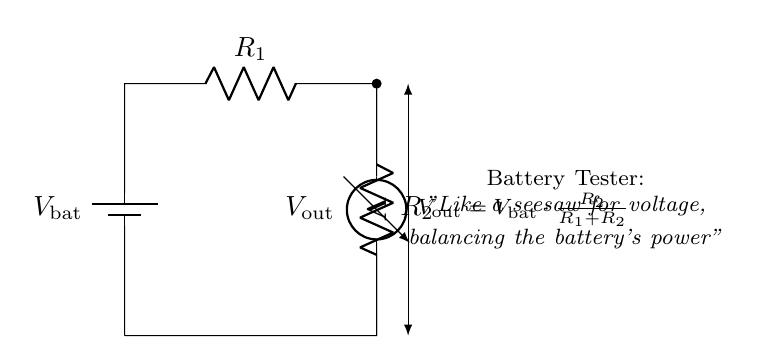What is the purpose of the voltage divider? The voltage divider is used to drop the battery voltage to a lower level suitable for measuring. It allows the voltmeter to display a proportional voltage based on the resistors used.
Answer: To obtain a lower voltage for measurement What are the values of the resistors? The resistors are labeled as R1 and R2, but specific numerical values are not provided in the diagram. Instead, their behavior is defined by their relative sizes in the voltage divider formula.
Answer: R1 and R2 (values not specified) What is the output voltage in relation to the battery voltage? The output voltage, labeled as Vout, is given by the formula Vout = Vbat multiplied by the ratio of R2 to the sum of R1 and R2. This relationship reveals how the voltage is shared between the resistors.
Answer: Vout = Vbat * (R2 / (R1 + R2)) What component measures the voltage? The voltmeter component in the circuit is responsible for measuring the output voltage across R2. It indicates the voltage level at that point in the circuit.
Answer: Voltmeter Why is the battery considered a low-power source? The battery is assumed to be a low-power source because it is likely providing a small amount of current, which is typical for applications like testing batteries with a voltmeter. The components are designed to handle low power.
Answer: Low power output What happens if R1 is much larger than R2? If R1 is much larger than R2, the output voltage Vout will be much lower than Vbat, as the majority of the voltage is dropped across R1. This can severely limit the measured voltage.
Answer: Vout approaches zero What analogy is given for this circuit? The analogy compares the circuit to a seesaw, indicating that it balances the battery's power through the arrangement of resistors, distributing voltage like weight over a fulcrum.
Answer: A seesaw for voltage 